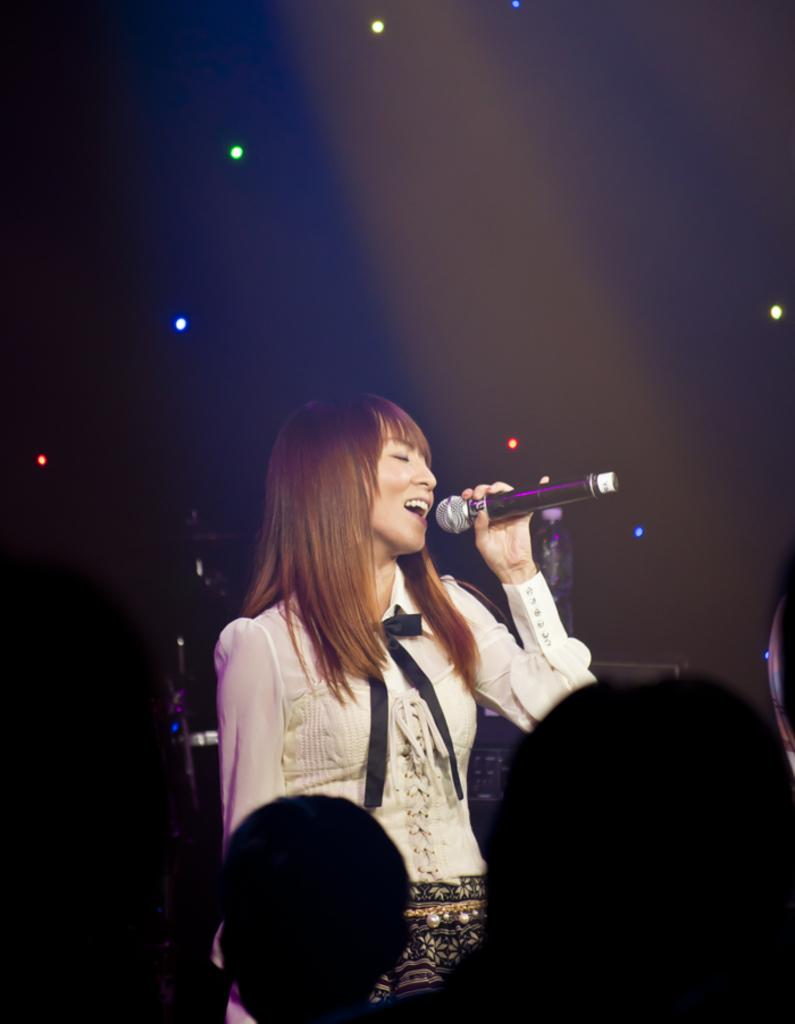Who is the main subject in the image? There is a girl in the image. What is the girl doing in the image? The girl is standing and singing into a microphone. Can you describe the microphone the girl is holding? The microphone is black in color. What type of tank can be seen in the background of the image? There is no tank present in the image. What order is the girl following while singing into the microphone? The provided facts do not mention any specific order the girl is following while singing. 